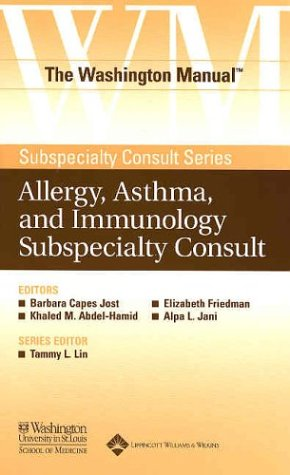Who are the primary target readers of this manual? The primary audience for this manual is medical professionals, particularly those specializing or needing detailed information on allergy, asthma, and immunology. It serves as a quick reference guide for doctors and healthcare providers. 